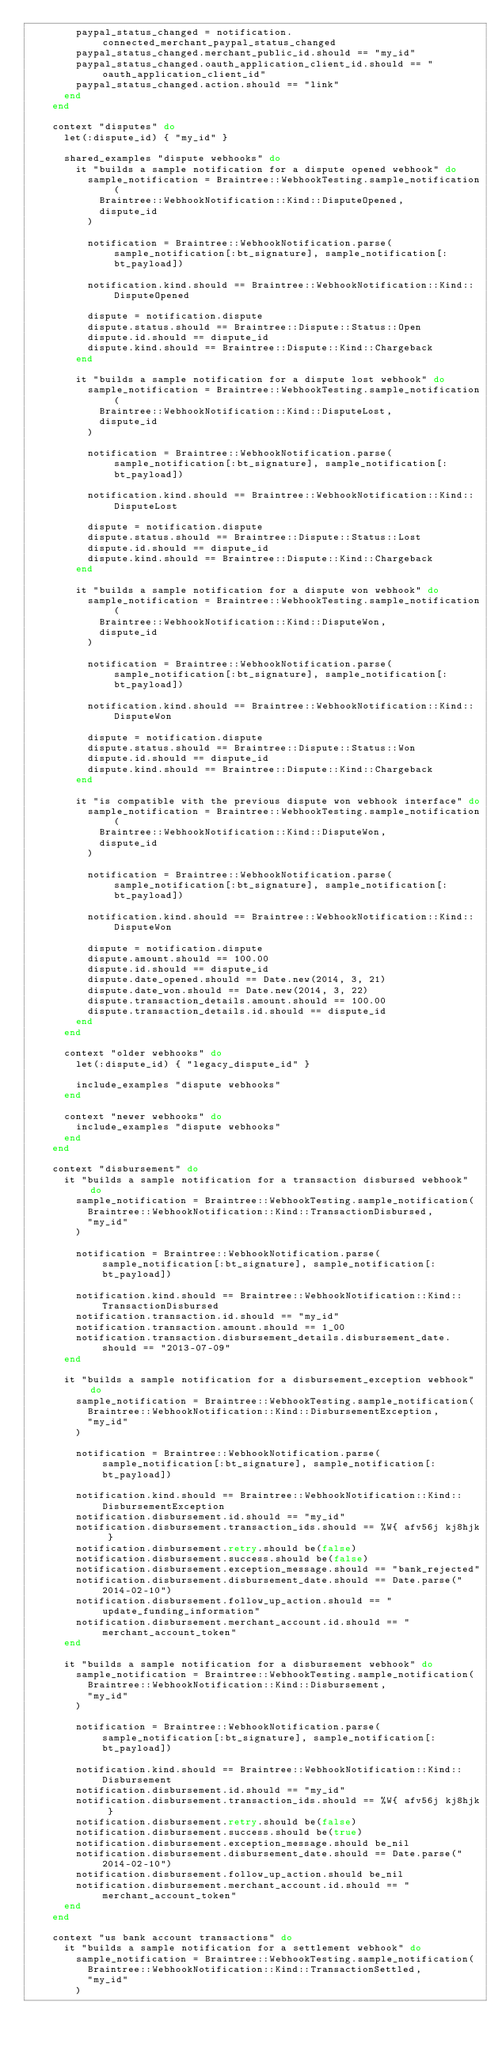<code> <loc_0><loc_0><loc_500><loc_500><_Ruby_>        paypal_status_changed = notification.connected_merchant_paypal_status_changed
        paypal_status_changed.merchant_public_id.should == "my_id"
        paypal_status_changed.oauth_application_client_id.should == "oauth_application_client_id"
        paypal_status_changed.action.should == "link"
      end
    end

    context "disputes" do
      let(:dispute_id) { "my_id" }

      shared_examples "dispute webhooks" do
        it "builds a sample notification for a dispute opened webhook" do
          sample_notification = Braintree::WebhookTesting.sample_notification(
            Braintree::WebhookNotification::Kind::DisputeOpened,
            dispute_id
          )

          notification = Braintree::WebhookNotification.parse(sample_notification[:bt_signature], sample_notification[:bt_payload])

          notification.kind.should == Braintree::WebhookNotification::Kind::DisputeOpened

          dispute = notification.dispute
          dispute.status.should == Braintree::Dispute::Status::Open
          dispute.id.should == dispute_id
          dispute.kind.should == Braintree::Dispute::Kind::Chargeback
        end

        it "builds a sample notification for a dispute lost webhook" do
          sample_notification = Braintree::WebhookTesting.sample_notification(
            Braintree::WebhookNotification::Kind::DisputeLost,
            dispute_id
          )

          notification = Braintree::WebhookNotification.parse(sample_notification[:bt_signature], sample_notification[:bt_payload])

          notification.kind.should == Braintree::WebhookNotification::Kind::DisputeLost

          dispute = notification.dispute
          dispute.status.should == Braintree::Dispute::Status::Lost
          dispute.id.should == dispute_id
          dispute.kind.should == Braintree::Dispute::Kind::Chargeback
        end

        it "builds a sample notification for a dispute won webhook" do
          sample_notification = Braintree::WebhookTesting.sample_notification(
            Braintree::WebhookNotification::Kind::DisputeWon,
            dispute_id
          )

          notification = Braintree::WebhookNotification.parse(sample_notification[:bt_signature], sample_notification[:bt_payload])

          notification.kind.should == Braintree::WebhookNotification::Kind::DisputeWon

          dispute = notification.dispute
          dispute.status.should == Braintree::Dispute::Status::Won
          dispute.id.should == dispute_id
          dispute.kind.should == Braintree::Dispute::Kind::Chargeback
        end

        it "is compatible with the previous dispute won webhook interface" do
          sample_notification = Braintree::WebhookTesting.sample_notification(
            Braintree::WebhookNotification::Kind::DisputeWon,
            dispute_id
          )

          notification = Braintree::WebhookNotification.parse(sample_notification[:bt_signature], sample_notification[:bt_payload])

          notification.kind.should == Braintree::WebhookNotification::Kind::DisputeWon

          dispute = notification.dispute
          dispute.amount.should == 100.00
          dispute.id.should == dispute_id
          dispute.date_opened.should == Date.new(2014, 3, 21)
          dispute.date_won.should == Date.new(2014, 3, 22)
          dispute.transaction_details.amount.should == 100.00
          dispute.transaction_details.id.should == dispute_id
        end
      end

      context "older webhooks" do
        let(:dispute_id) { "legacy_dispute_id" }

        include_examples "dispute webhooks"
      end

      context "newer webhooks" do
        include_examples "dispute webhooks"
      end
    end

    context "disbursement" do
      it "builds a sample notification for a transaction disbursed webhook" do
        sample_notification = Braintree::WebhookTesting.sample_notification(
          Braintree::WebhookNotification::Kind::TransactionDisbursed,
          "my_id"
        )

        notification = Braintree::WebhookNotification.parse(sample_notification[:bt_signature], sample_notification[:bt_payload])

        notification.kind.should == Braintree::WebhookNotification::Kind::TransactionDisbursed
        notification.transaction.id.should == "my_id"
        notification.transaction.amount.should == 1_00
        notification.transaction.disbursement_details.disbursement_date.should == "2013-07-09"
      end

      it "builds a sample notification for a disbursement_exception webhook" do
        sample_notification = Braintree::WebhookTesting.sample_notification(
          Braintree::WebhookNotification::Kind::DisbursementException,
          "my_id"
        )

        notification = Braintree::WebhookNotification.parse(sample_notification[:bt_signature], sample_notification[:bt_payload])

        notification.kind.should == Braintree::WebhookNotification::Kind::DisbursementException
        notification.disbursement.id.should == "my_id"
        notification.disbursement.transaction_ids.should == %W{ afv56j kj8hjk }
        notification.disbursement.retry.should be(false)
        notification.disbursement.success.should be(false)
        notification.disbursement.exception_message.should == "bank_rejected"
        notification.disbursement.disbursement_date.should == Date.parse("2014-02-10")
        notification.disbursement.follow_up_action.should == "update_funding_information"
        notification.disbursement.merchant_account.id.should == "merchant_account_token"
      end

      it "builds a sample notification for a disbursement webhook" do
        sample_notification = Braintree::WebhookTesting.sample_notification(
          Braintree::WebhookNotification::Kind::Disbursement,
          "my_id"
        )

        notification = Braintree::WebhookNotification.parse(sample_notification[:bt_signature], sample_notification[:bt_payload])

        notification.kind.should == Braintree::WebhookNotification::Kind::Disbursement
        notification.disbursement.id.should == "my_id"
        notification.disbursement.transaction_ids.should == %W{ afv56j kj8hjk }
        notification.disbursement.retry.should be(false)
        notification.disbursement.success.should be(true)
        notification.disbursement.exception_message.should be_nil
        notification.disbursement.disbursement_date.should == Date.parse("2014-02-10")
        notification.disbursement.follow_up_action.should be_nil
        notification.disbursement.merchant_account.id.should == "merchant_account_token"
      end
    end

    context "us bank account transactions" do
      it "builds a sample notification for a settlement webhook" do
        sample_notification = Braintree::WebhookTesting.sample_notification(
          Braintree::WebhookNotification::Kind::TransactionSettled,
          "my_id"
        )
</code> 